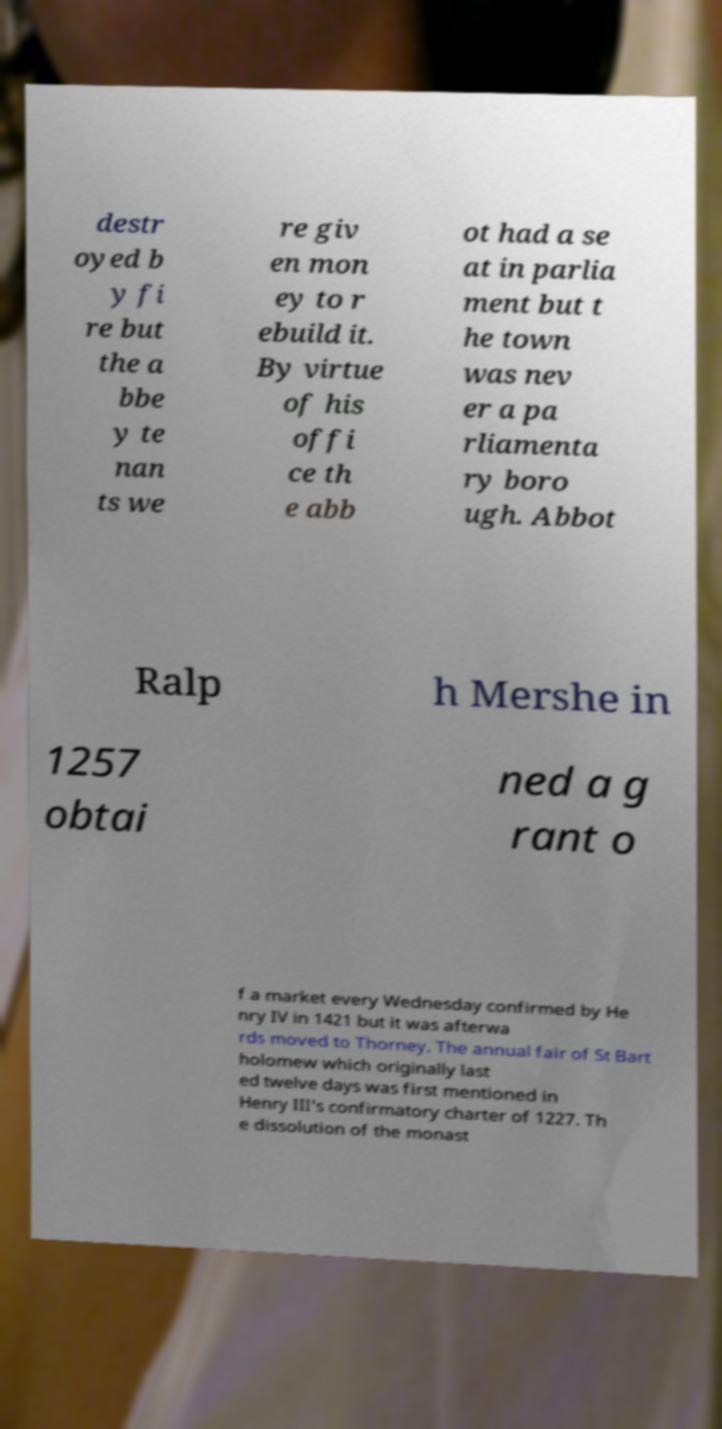There's text embedded in this image that I need extracted. Can you transcribe it verbatim? destr oyed b y fi re but the a bbe y te nan ts we re giv en mon ey to r ebuild it. By virtue of his offi ce th e abb ot had a se at in parlia ment but t he town was nev er a pa rliamenta ry boro ugh. Abbot Ralp h Mershe in 1257 obtai ned a g rant o f a market every Wednesday confirmed by He nry IV in 1421 but it was afterwa rds moved to Thorney. The annual fair of St Bart holomew which originally last ed twelve days was first mentioned in Henry III's confirmatory charter of 1227. Th e dissolution of the monast 